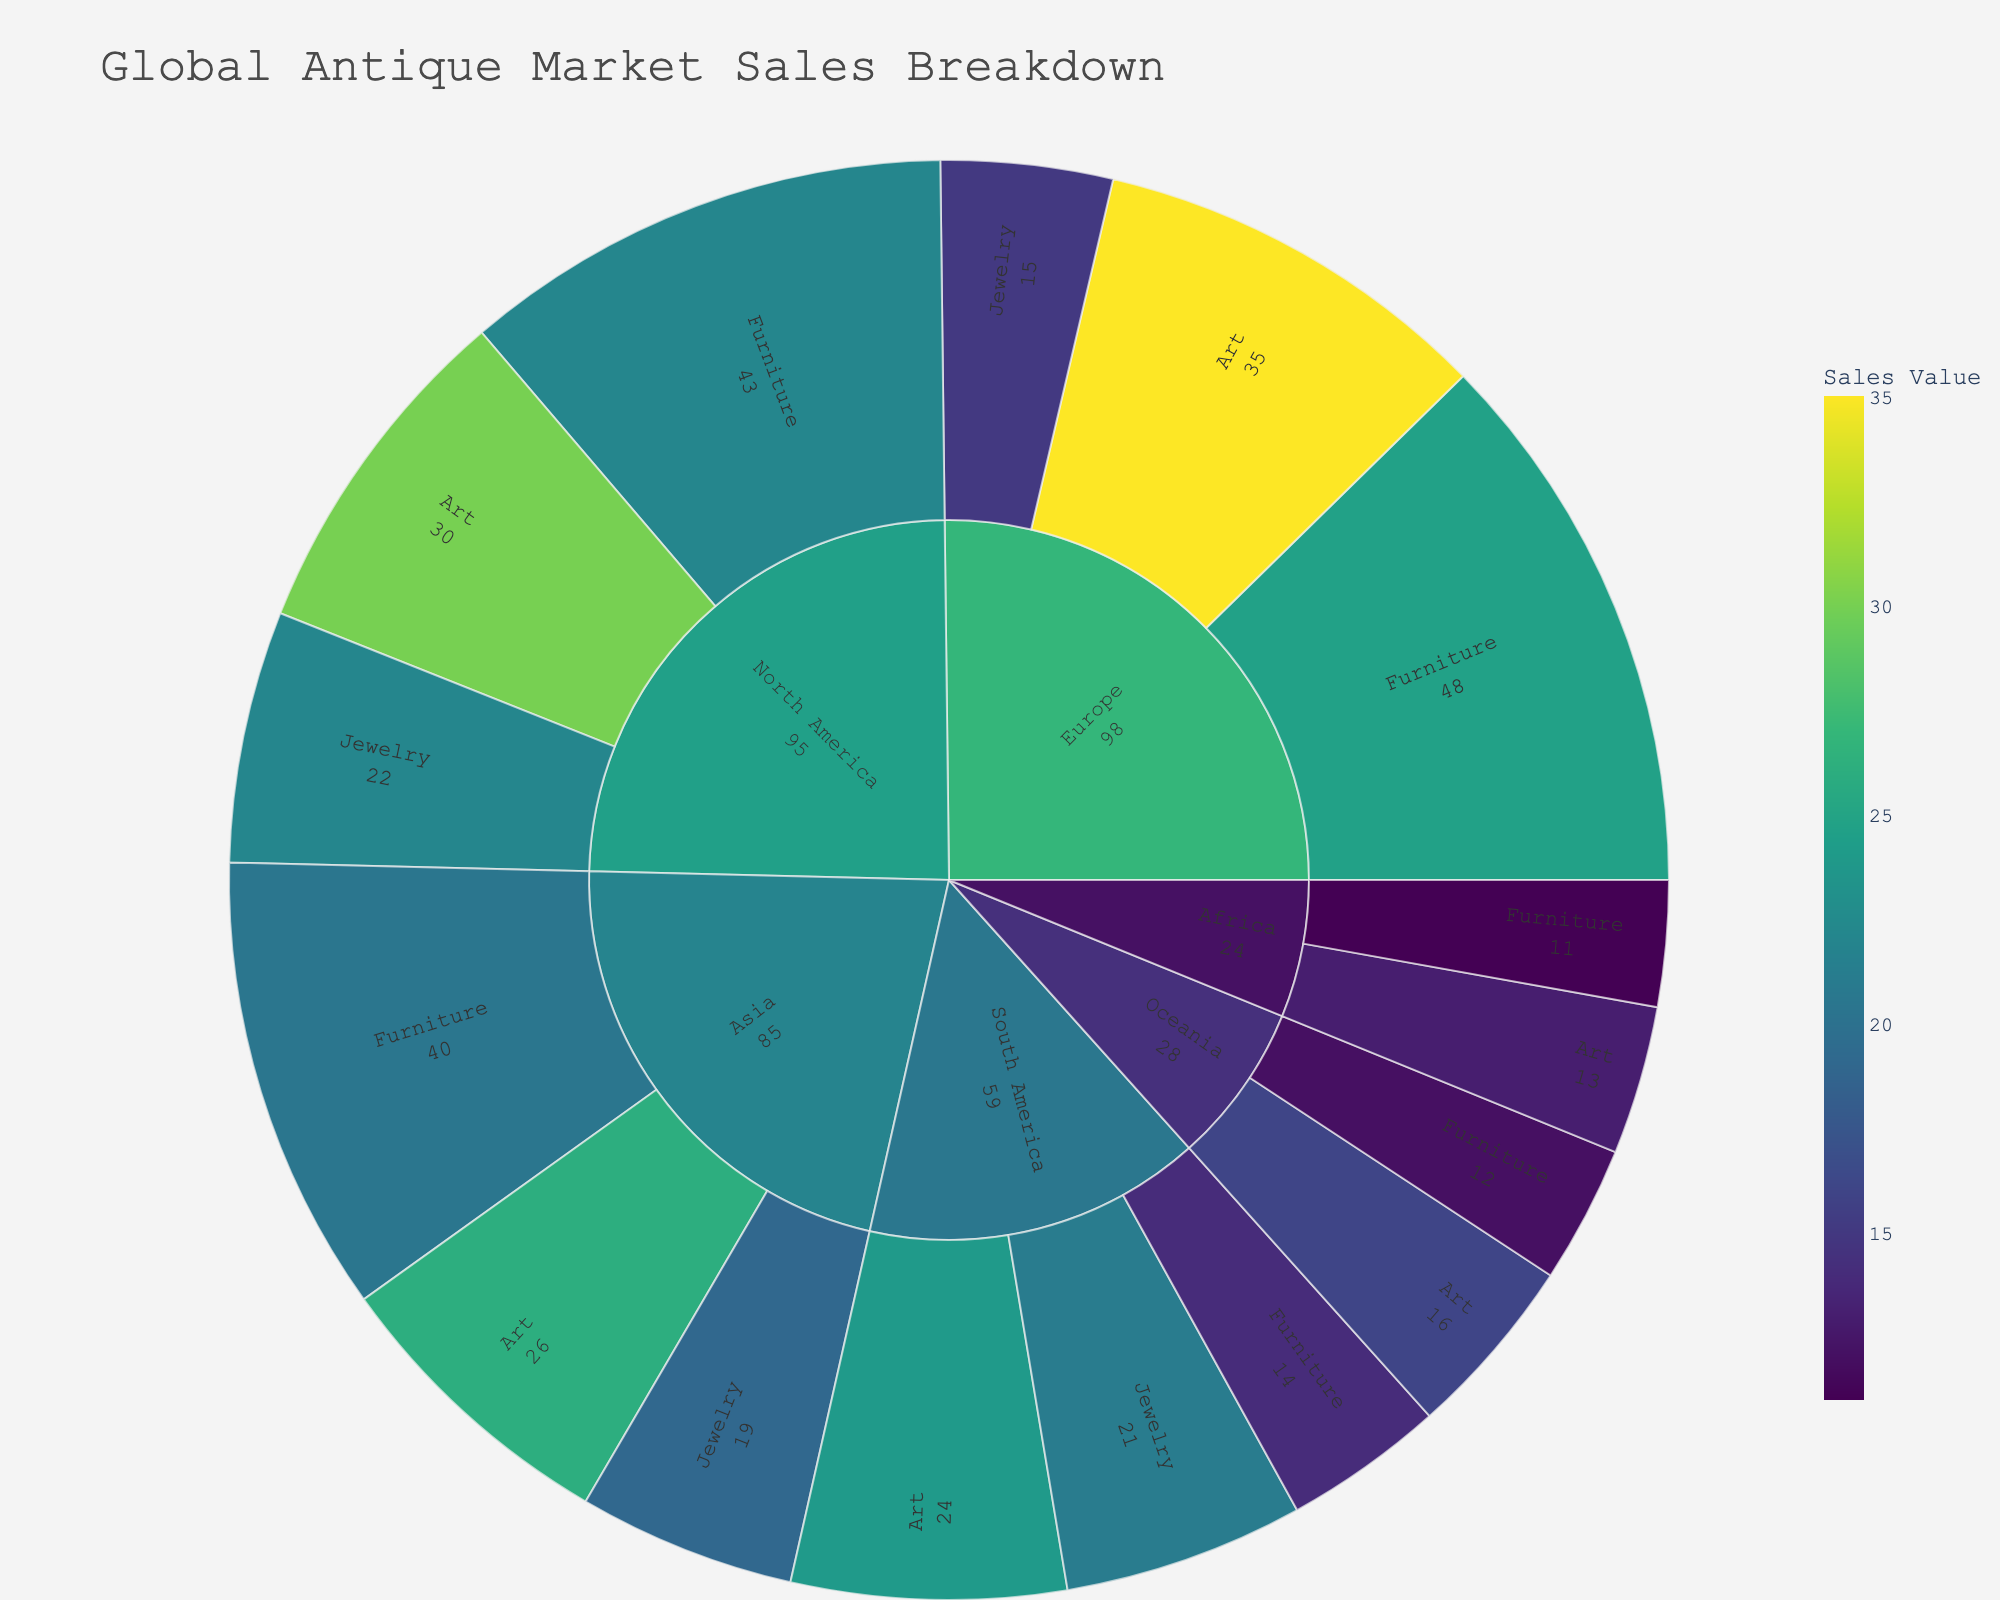What's the main title of the Sunburst Plot? The main title of the plot usually appears at the top and provides a summary of the chart's data. Here, the title is displayed as 'Global Antique Market Sales Breakdown'.
Answer: Global Antique Market Sales Breakdown Which region has the highest sales value for 'Jewelry'? To find which region has the highest sales value for 'Jewelry', check under the 'Jewelry' category and compare the sales values of all the regions. North America has 22, Europe has 15, Asia has 19, and South America has 21. So, North America has the highest.
Answer: North America How many categories of antiques are represented in the plot? The categories of antiques are the first level beneath each region in the Sunburst chart. They can be Furniture, Jewelry, and Art.
Answer: 3 What's the total sales value for the 'Furniture' category in Europe? To find this, look at the values belonging to the 'Furniture' category under Europe and sum them up. The values are Louis XV Armoires (28) and Georgian Sideboards (20). So, the total is 28 + 20 = 48.
Answer: 48 Which region sells 'Tribal Masks'? To find this, locate the 'Tribal Masks' label in the Sunburst plot and track it back to its parent region. 'Tribal Masks' is under the 'Art' category in Africa.
Answer: Africa Which furniture item has the lowest sales value, and in which region is it located? In the 'Furniture' category, compare all the sales values and look for the lowest one. Moroccan Inlaid Tables in Africa has the lowest value at 11.
Answer: Moroccan Inlaid Tables in Africa Compare the sales of 'Art' in Asia and Europe. Which region has higher sales and by how much? To find the difference, first determine the sales values of 'Art' in both regions. Asia has Edo Period Scrolls valued at 26, and Europe has Renaissance Sculptures valued at 35. The difference is 35 - 26 = 9, so Europe has higher sales by 9.
Answer: Europe by 9 What is the combined sales value for all antique items in North America? Sum up all the sales values for North America's items: Victorian Chairs (25), Art Deco Tables (18), Art Nouveau Brooches (22), and Impressionist Paintings (30). The total is 25 + 18 + 22 + 30 = 95.
Answer: 95 Which art item has the highest sales value, and what is its category? Check the 'Art' section to compare the sales values. The highest value in the category is Renaissance Sculptures at 35.
Answer: Renaissance Sculptures Between 'Jewelry' and 'Furniture,' which category has more sales in South America? Sum up the values for each category in South America. Jewelry has Pre-Columbian Gold Artifacts (21), and Furniture has Colonial Spanish Desks (14). Jewelry's value (21) is greater than Furniture's (14).
Answer: Jewelry 